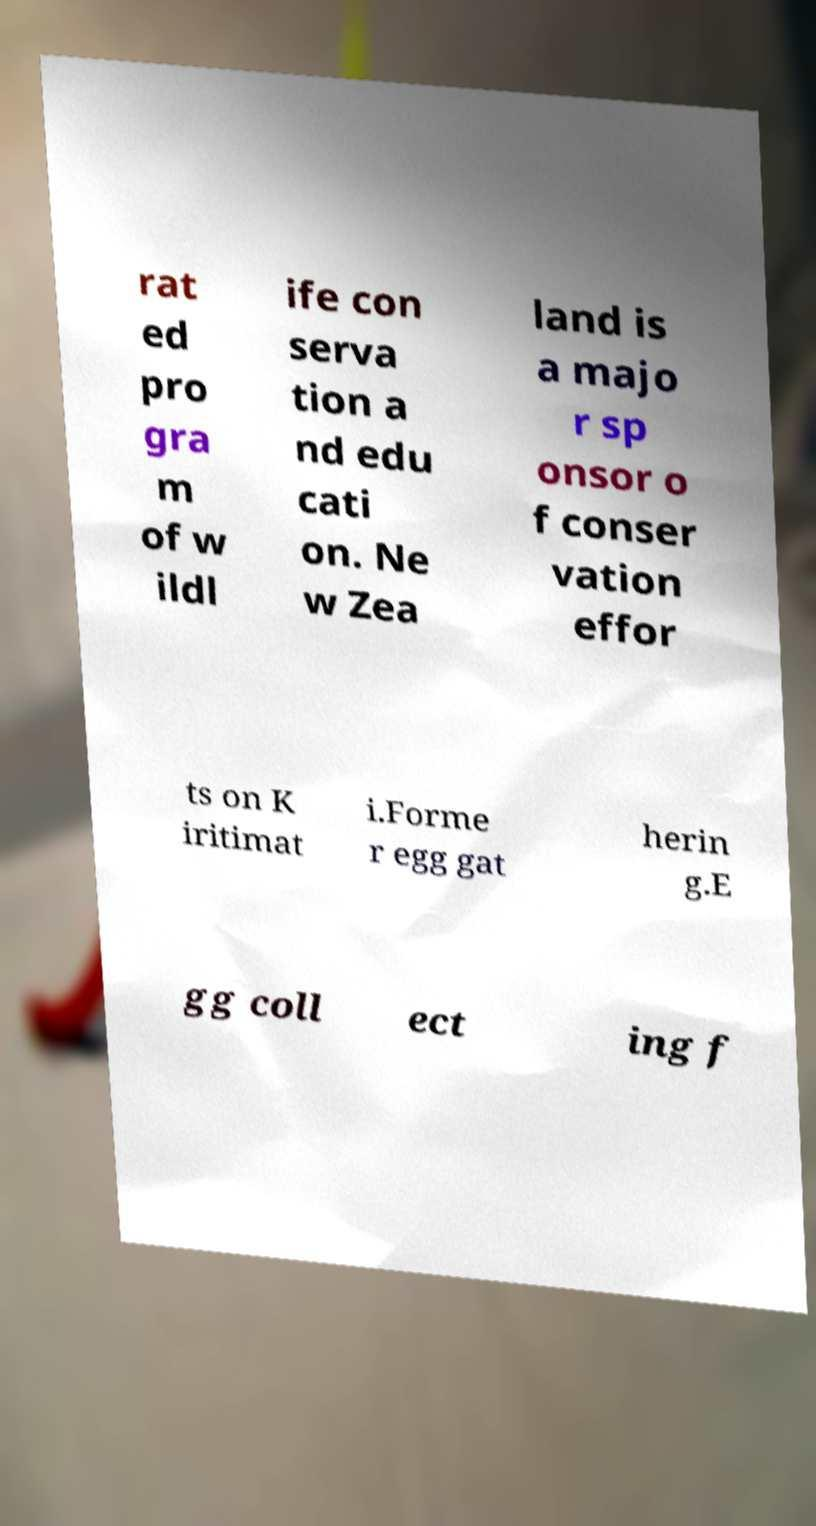Can you accurately transcribe the text from the provided image for me? rat ed pro gra m of w ildl ife con serva tion a nd edu cati on. Ne w Zea land is a majo r sp onsor o f conser vation effor ts on K iritimat i.Forme r egg gat herin g.E gg coll ect ing f 